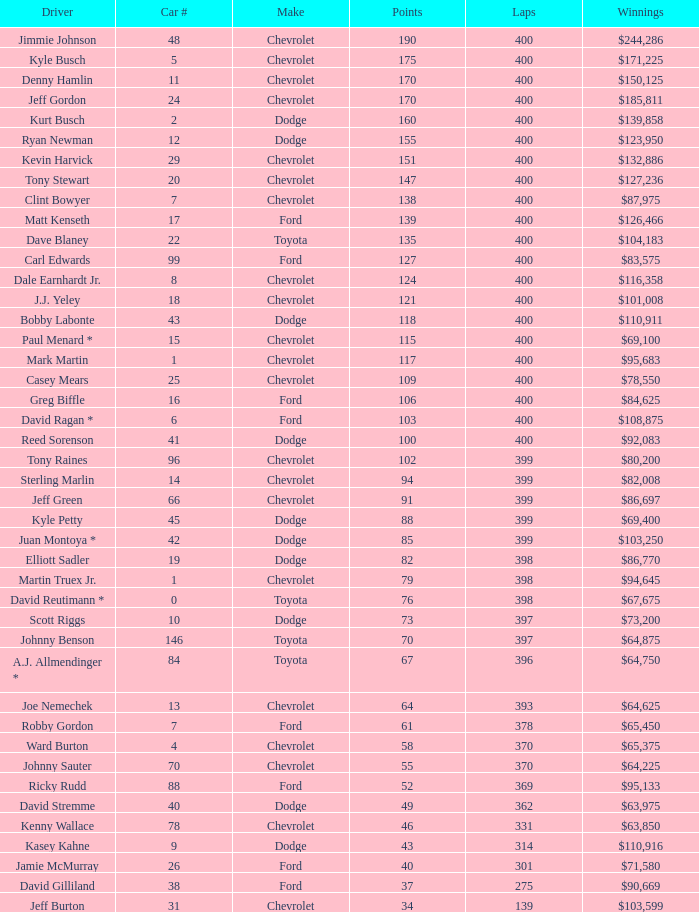What is the automobile number with less than 369 laps for a dodge possessing more than 49 points? None. 